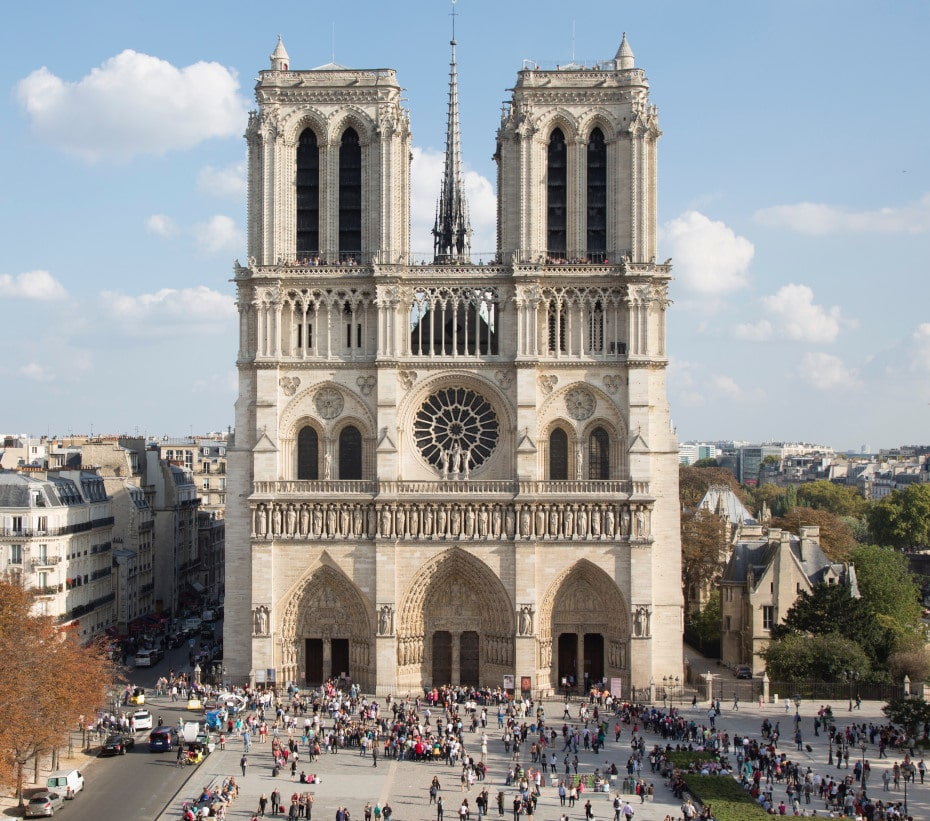What are some unique architectural features of the cathedral visible in the image? The image distinctly showcases several unique architectural features of the Notre Dame Cathedral. Key elements include the imposing twin towers that frame the central facade, each adorned with intricately carved arched windows and culminating in pointed spires. The large rose window at the center is another standout feature, notable for its detailed tracery and stained glass artwork. The tall and slender spire rising in the middle of the cathedral is an epitome of Gothic verticality, reaching skyward and adding to the overall grandeur. Additionally, the details in the stone carvings around the entrance and the consistency of the light-colored stone used throughout the facade enhance the cathedral's majestic aura. Can you describe the historical significance of the square in front of the cathedral? The square in front of the Notre Dame Cathedral, known as the Parvis Notre-Dame - Place Jean-Paul II, holds substantial historical significance. Historically, it has served as a central gathering point for Parisians and visitors alike, playing host to numerous significant events and public gatherings over the centuries. It's a place where the history of Paris and France has unfolded, from medieval times through the French Revolution and into the modern era. The square is not just a physical space but a witness to the ebb and flow of the city's vibrant history, reflecting the social and cultural changes that have shaped Paris. If the cathedral's spire could speak, what stories might it tell? If the spire of Notre Dame Cathedral could speak, it would recount tales of centuries gone by. It would tell of the craftsmen who painstakingly built it, their lives intertwined with each stone they placed. It would speak of viewing the transformation of Paris from a medieval city to the bustling metropolis of today, standing tall through wars, revolutions, and the relentless march of time. The spire would share the echoes of the bells that ring in celebration and mourning, the prayers of countless souls who have sought solace within the cathedral walls, and the breathtaking views of a constantly evolving Parisian skyline seen from its lofty peak. 